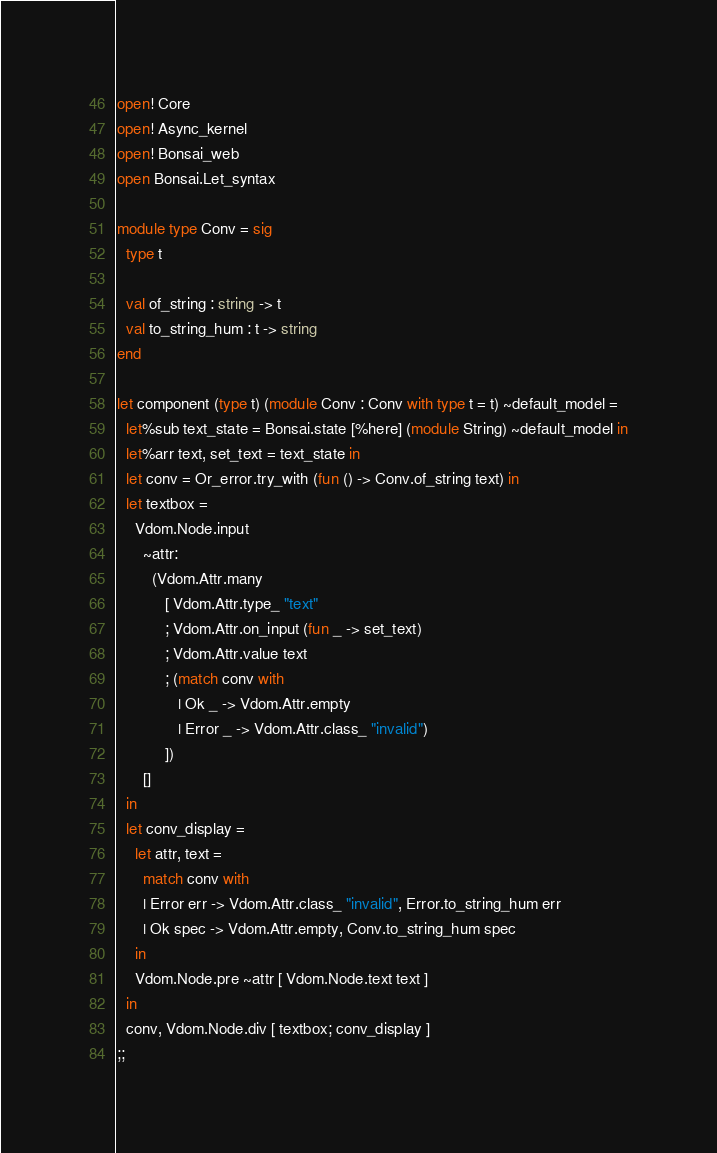<code> <loc_0><loc_0><loc_500><loc_500><_OCaml_>open! Core
open! Async_kernel
open! Bonsai_web
open Bonsai.Let_syntax

module type Conv = sig
  type t

  val of_string : string -> t
  val to_string_hum : t -> string
end

let component (type t) (module Conv : Conv with type t = t) ~default_model =
  let%sub text_state = Bonsai.state [%here] (module String) ~default_model in
  let%arr text, set_text = text_state in
  let conv = Or_error.try_with (fun () -> Conv.of_string text) in
  let textbox =
    Vdom.Node.input
      ~attr:
        (Vdom.Attr.many
           [ Vdom.Attr.type_ "text"
           ; Vdom.Attr.on_input (fun _ -> set_text)
           ; Vdom.Attr.value text
           ; (match conv with
              | Ok _ -> Vdom.Attr.empty
              | Error _ -> Vdom.Attr.class_ "invalid")
           ])
      []
  in
  let conv_display =
    let attr, text =
      match conv with
      | Error err -> Vdom.Attr.class_ "invalid", Error.to_string_hum err
      | Ok spec -> Vdom.Attr.empty, Conv.to_string_hum spec
    in
    Vdom.Node.pre ~attr [ Vdom.Node.text text ]
  in
  conv, Vdom.Node.div [ textbox; conv_display ]
;;
</code> 